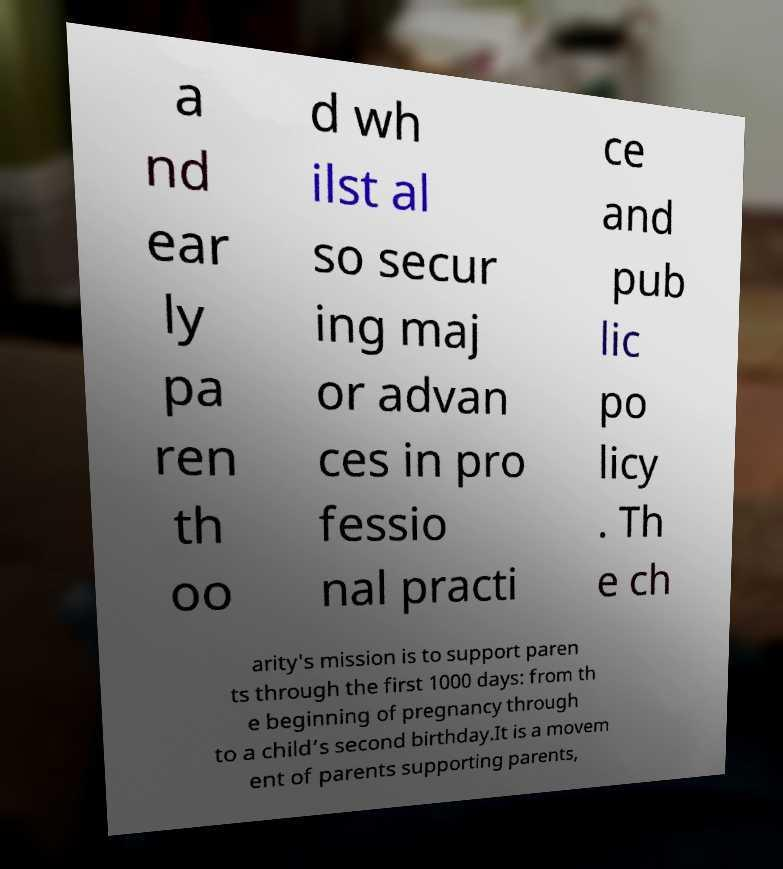I need the written content from this picture converted into text. Can you do that? a nd ear ly pa ren th oo d wh ilst al so secur ing maj or advan ces in pro fessio nal practi ce and pub lic po licy . Th e ch arity's mission is to support paren ts through the first 1000 days: from th e beginning of pregnancy through to a child’s second birthday.It is a movem ent of parents supporting parents, 